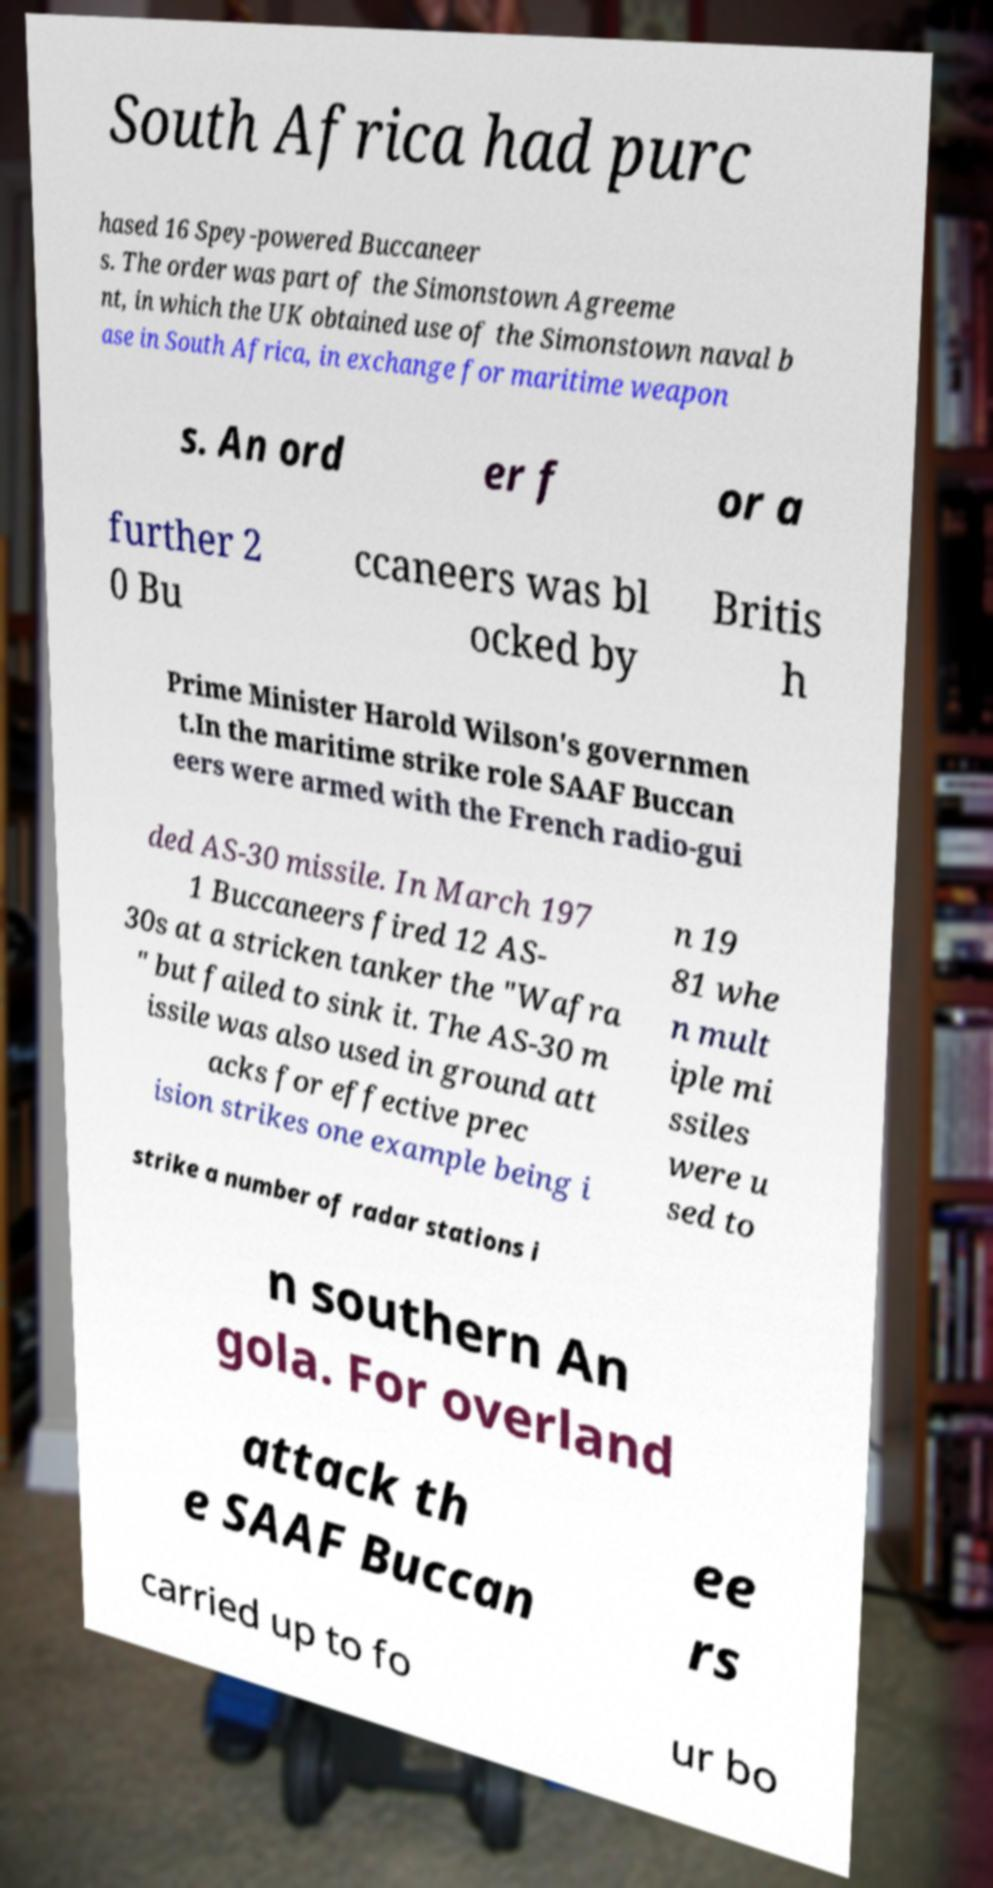There's text embedded in this image that I need extracted. Can you transcribe it verbatim? South Africa had purc hased 16 Spey-powered Buccaneer s. The order was part of the Simonstown Agreeme nt, in which the UK obtained use of the Simonstown naval b ase in South Africa, in exchange for maritime weapon s. An ord er f or a further 2 0 Bu ccaneers was bl ocked by Britis h Prime Minister Harold Wilson's governmen t.In the maritime strike role SAAF Buccan eers were armed with the French radio-gui ded AS-30 missile. In March 197 1 Buccaneers fired 12 AS- 30s at a stricken tanker the "Wafra " but failed to sink it. The AS-30 m issile was also used in ground att acks for effective prec ision strikes one example being i n 19 81 whe n mult iple mi ssiles were u sed to strike a number of radar stations i n southern An gola. For overland attack th e SAAF Buccan ee rs carried up to fo ur bo 